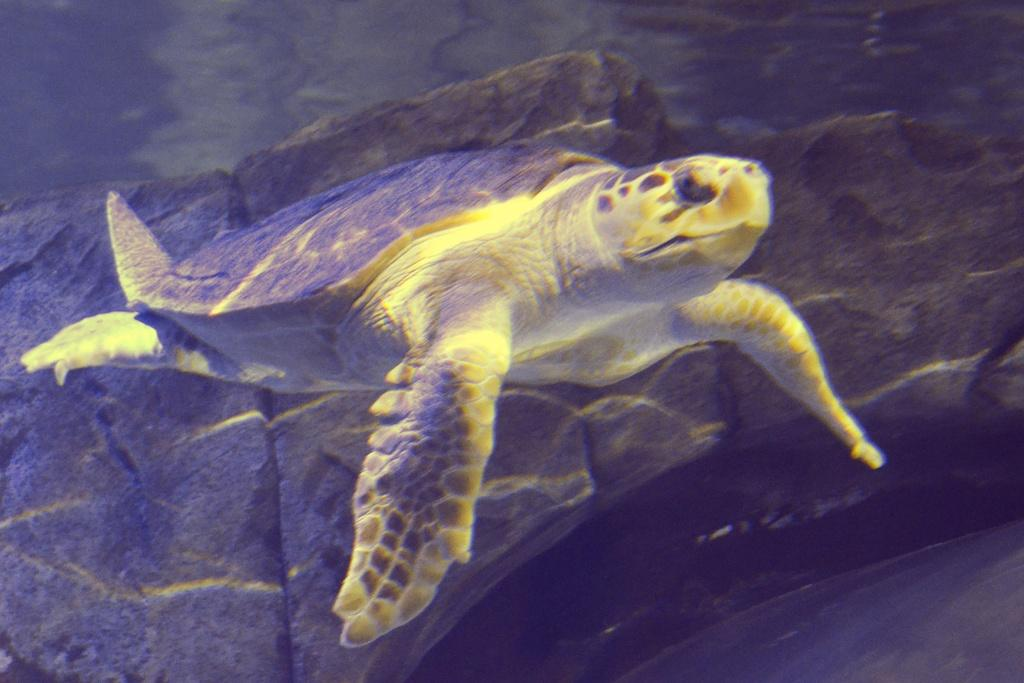What type of animal is present in the image? There is a tortoise in the image. What is located behind the tortoise in the image? There is a rock behind the tortoise in the image. How many times does the tortoise kiss the floor in the image? The tortoise does not kiss the floor in the image, as tortoises do not have the ability to kiss. 